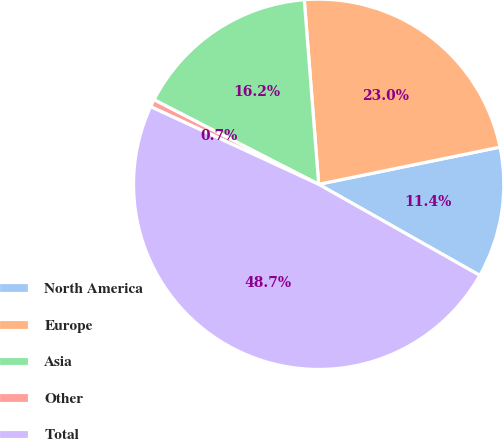<chart> <loc_0><loc_0><loc_500><loc_500><pie_chart><fcel>North America<fcel>Europe<fcel>Asia<fcel>Other<fcel>Total<nl><fcel>11.41%<fcel>23.02%<fcel>16.21%<fcel>0.66%<fcel>48.7%<nl></chart> 